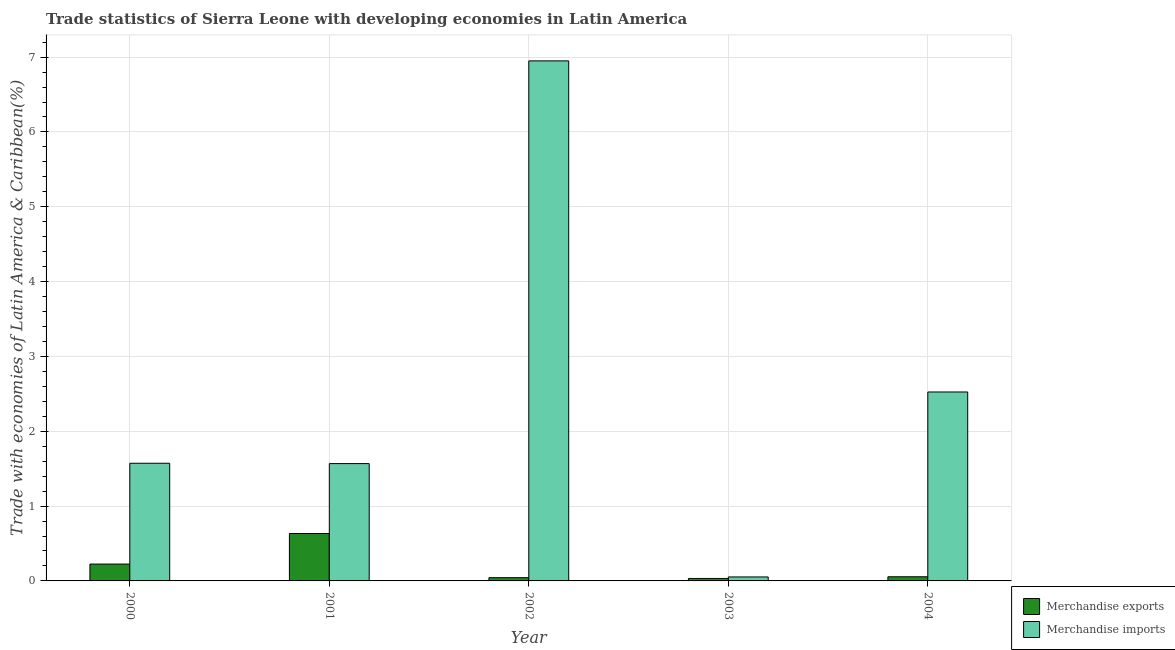How many different coloured bars are there?
Provide a succinct answer. 2. Are the number of bars on each tick of the X-axis equal?
Ensure brevity in your answer.  Yes. What is the merchandise exports in 2003?
Offer a very short reply. 0.03. Across all years, what is the maximum merchandise exports?
Give a very brief answer. 0.63. Across all years, what is the minimum merchandise exports?
Provide a short and direct response. 0.03. In which year was the merchandise exports maximum?
Keep it short and to the point. 2001. What is the total merchandise exports in the graph?
Offer a very short reply. 0.99. What is the difference between the merchandise imports in 2000 and that in 2001?
Your answer should be very brief. 0. What is the difference between the merchandise imports in 2003 and the merchandise exports in 2002?
Your answer should be very brief. -6.9. What is the average merchandise imports per year?
Your answer should be very brief. 2.53. In how many years, is the merchandise imports greater than 1 %?
Offer a very short reply. 4. What is the ratio of the merchandise exports in 2002 to that in 2003?
Provide a succinct answer. 1.32. Is the difference between the merchandise exports in 2000 and 2004 greater than the difference between the merchandise imports in 2000 and 2004?
Offer a terse response. No. What is the difference between the highest and the second highest merchandise imports?
Offer a very short reply. 4.42. What is the difference between the highest and the lowest merchandise imports?
Give a very brief answer. 6.9. Is the sum of the merchandise imports in 2001 and 2002 greater than the maximum merchandise exports across all years?
Provide a short and direct response. Yes. What does the 2nd bar from the right in 2002 represents?
Your answer should be very brief. Merchandise exports. How many years are there in the graph?
Give a very brief answer. 5. What is the difference between two consecutive major ticks on the Y-axis?
Your answer should be compact. 1. Are the values on the major ticks of Y-axis written in scientific E-notation?
Provide a short and direct response. No. Does the graph contain any zero values?
Offer a very short reply. No. Where does the legend appear in the graph?
Keep it short and to the point. Bottom right. How many legend labels are there?
Make the answer very short. 2. How are the legend labels stacked?
Give a very brief answer. Vertical. What is the title of the graph?
Offer a very short reply. Trade statistics of Sierra Leone with developing economies in Latin America. What is the label or title of the X-axis?
Offer a very short reply. Year. What is the label or title of the Y-axis?
Keep it short and to the point. Trade with economies of Latin America & Caribbean(%). What is the Trade with economies of Latin America & Caribbean(%) of Merchandise exports in 2000?
Your response must be concise. 0.23. What is the Trade with economies of Latin America & Caribbean(%) of Merchandise imports in 2000?
Offer a very short reply. 1.57. What is the Trade with economies of Latin America & Caribbean(%) in Merchandise exports in 2001?
Provide a succinct answer. 0.63. What is the Trade with economies of Latin America & Caribbean(%) in Merchandise imports in 2001?
Offer a very short reply. 1.57. What is the Trade with economies of Latin America & Caribbean(%) of Merchandise exports in 2002?
Your answer should be compact. 0.04. What is the Trade with economies of Latin America & Caribbean(%) of Merchandise imports in 2002?
Offer a very short reply. 6.95. What is the Trade with economies of Latin America & Caribbean(%) of Merchandise exports in 2003?
Provide a short and direct response. 0.03. What is the Trade with economies of Latin America & Caribbean(%) of Merchandise imports in 2003?
Keep it short and to the point. 0.05. What is the Trade with economies of Latin America & Caribbean(%) of Merchandise exports in 2004?
Give a very brief answer. 0.06. What is the Trade with economies of Latin America & Caribbean(%) of Merchandise imports in 2004?
Your response must be concise. 2.53. Across all years, what is the maximum Trade with economies of Latin America & Caribbean(%) in Merchandise exports?
Your answer should be very brief. 0.63. Across all years, what is the maximum Trade with economies of Latin America & Caribbean(%) in Merchandise imports?
Offer a terse response. 6.95. Across all years, what is the minimum Trade with economies of Latin America & Caribbean(%) of Merchandise exports?
Your answer should be compact. 0.03. Across all years, what is the minimum Trade with economies of Latin America & Caribbean(%) of Merchandise imports?
Keep it short and to the point. 0.05. What is the total Trade with economies of Latin America & Caribbean(%) of Merchandise exports in the graph?
Your response must be concise. 0.99. What is the total Trade with economies of Latin America & Caribbean(%) of Merchandise imports in the graph?
Provide a short and direct response. 12.67. What is the difference between the Trade with economies of Latin America & Caribbean(%) in Merchandise exports in 2000 and that in 2001?
Offer a very short reply. -0.41. What is the difference between the Trade with economies of Latin America & Caribbean(%) in Merchandise imports in 2000 and that in 2001?
Provide a succinct answer. 0. What is the difference between the Trade with economies of Latin America & Caribbean(%) of Merchandise exports in 2000 and that in 2002?
Give a very brief answer. 0.18. What is the difference between the Trade with economies of Latin America & Caribbean(%) in Merchandise imports in 2000 and that in 2002?
Make the answer very short. -5.38. What is the difference between the Trade with economies of Latin America & Caribbean(%) of Merchandise exports in 2000 and that in 2003?
Keep it short and to the point. 0.19. What is the difference between the Trade with economies of Latin America & Caribbean(%) in Merchandise imports in 2000 and that in 2003?
Give a very brief answer. 1.52. What is the difference between the Trade with economies of Latin America & Caribbean(%) in Merchandise exports in 2000 and that in 2004?
Offer a very short reply. 0.17. What is the difference between the Trade with economies of Latin America & Caribbean(%) of Merchandise imports in 2000 and that in 2004?
Provide a short and direct response. -0.95. What is the difference between the Trade with economies of Latin America & Caribbean(%) in Merchandise exports in 2001 and that in 2002?
Offer a terse response. 0.59. What is the difference between the Trade with economies of Latin America & Caribbean(%) of Merchandise imports in 2001 and that in 2002?
Ensure brevity in your answer.  -5.38. What is the difference between the Trade with economies of Latin America & Caribbean(%) of Merchandise exports in 2001 and that in 2003?
Your answer should be compact. 0.6. What is the difference between the Trade with economies of Latin America & Caribbean(%) of Merchandise imports in 2001 and that in 2003?
Offer a terse response. 1.51. What is the difference between the Trade with economies of Latin America & Caribbean(%) of Merchandise exports in 2001 and that in 2004?
Keep it short and to the point. 0.58. What is the difference between the Trade with economies of Latin America & Caribbean(%) of Merchandise imports in 2001 and that in 2004?
Keep it short and to the point. -0.96. What is the difference between the Trade with economies of Latin America & Caribbean(%) of Merchandise exports in 2002 and that in 2003?
Keep it short and to the point. 0.01. What is the difference between the Trade with economies of Latin America & Caribbean(%) in Merchandise imports in 2002 and that in 2003?
Provide a succinct answer. 6.9. What is the difference between the Trade with economies of Latin America & Caribbean(%) of Merchandise exports in 2002 and that in 2004?
Make the answer very short. -0.01. What is the difference between the Trade with economies of Latin America & Caribbean(%) of Merchandise imports in 2002 and that in 2004?
Your answer should be very brief. 4.42. What is the difference between the Trade with economies of Latin America & Caribbean(%) of Merchandise exports in 2003 and that in 2004?
Give a very brief answer. -0.02. What is the difference between the Trade with economies of Latin America & Caribbean(%) of Merchandise imports in 2003 and that in 2004?
Ensure brevity in your answer.  -2.47. What is the difference between the Trade with economies of Latin America & Caribbean(%) of Merchandise exports in 2000 and the Trade with economies of Latin America & Caribbean(%) of Merchandise imports in 2001?
Your response must be concise. -1.34. What is the difference between the Trade with economies of Latin America & Caribbean(%) of Merchandise exports in 2000 and the Trade with economies of Latin America & Caribbean(%) of Merchandise imports in 2002?
Give a very brief answer. -6.72. What is the difference between the Trade with economies of Latin America & Caribbean(%) in Merchandise exports in 2000 and the Trade with economies of Latin America & Caribbean(%) in Merchandise imports in 2003?
Your answer should be compact. 0.17. What is the difference between the Trade with economies of Latin America & Caribbean(%) in Merchandise exports in 2000 and the Trade with economies of Latin America & Caribbean(%) in Merchandise imports in 2004?
Your answer should be compact. -2.3. What is the difference between the Trade with economies of Latin America & Caribbean(%) of Merchandise exports in 2001 and the Trade with economies of Latin America & Caribbean(%) of Merchandise imports in 2002?
Give a very brief answer. -6.32. What is the difference between the Trade with economies of Latin America & Caribbean(%) of Merchandise exports in 2001 and the Trade with economies of Latin America & Caribbean(%) of Merchandise imports in 2003?
Your answer should be very brief. 0.58. What is the difference between the Trade with economies of Latin America & Caribbean(%) in Merchandise exports in 2001 and the Trade with economies of Latin America & Caribbean(%) in Merchandise imports in 2004?
Offer a terse response. -1.89. What is the difference between the Trade with economies of Latin America & Caribbean(%) in Merchandise exports in 2002 and the Trade with economies of Latin America & Caribbean(%) in Merchandise imports in 2003?
Keep it short and to the point. -0.01. What is the difference between the Trade with economies of Latin America & Caribbean(%) in Merchandise exports in 2002 and the Trade with economies of Latin America & Caribbean(%) in Merchandise imports in 2004?
Give a very brief answer. -2.48. What is the difference between the Trade with economies of Latin America & Caribbean(%) in Merchandise exports in 2003 and the Trade with economies of Latin America & Caribbean(%) in Merchandise imports in 2004?
Your answer should be very brief. -2.49. What is the average Trade with economies of Latin America & Caribbean(%) of Merchandise exports per year?
Make the answer very short. 0.2. What is the average Trade with economies of Latin America & Caribbean(%) of Merchandise imports per year?
Your answer should be compact. 2.53. In the year 2000, what is the difference between the Trade with economies of Latin America & Caribbean(%) of Merchandise exports and Trade with economies of Latin America & Caribbean(%) of Merchandise imports?
Offer a very short reply. -1.35. In the year 2001, what is the difference between the Trade with economies of Latin America & Caribbean(%) of Merchandise exports and Trade with economies of Latin America & Caribbean(%) of Merchandise imports?
Your response must be concise. -0.93. In the year 2002, what is the difference between the Trade with economies of Latin America & Caribbean(%) in Merchandise exports and Trade with economies of Latin America & Caribbean(%) in Merchandise imports?
Your answer should be very brief. -6.91. In the year 2003, what is the difference between the Trade with economies of Latin America & Caribbean(%) in Merchandise exports and Trade with economies of Latin America & Caribbean(%) in Merchandise imports?
Your answer should be very brief. -0.02. In the year 2004, what is the difference between the Trade with economies of Latin America & Caribbean(%) in Merchandise exports and Trade with economies of Latin America & Caribbean(%) in Merchandise imports?
Offer a very short reply. -2.47. What is the ratio of the Trade with economies of Latin America & Caribbean(%) of Merchandise exports in 2000 to that in 2001?
Offer a terse response. 0.36. What is the ratio of the Trade with economies of Latin America & Caribbean(%) in Merchandise imports in 2000 to that in 2001?
Your answer should be compact. 1. What is the ratio of the Trade with economies of Latin America & Caribbean(%) in Merchandise exports in 2000 to that in 2002?
Offer a terse response. 5.2. What is the ratio of the Trade with economies of Latin America & Caribbean(%) in Merchandise imports in 2000 to that in 2002?
Give a very brief answer. 0.23. What is the ratio of the Trade with economies of Latin America & Caribbean(%) of Merchandise exports in 2000 to that in 2003?
Ensure brevity in your answer.  6.85. What is the ratio of the Trade with economies of Latin America & Caribbean(%) in Merchandise imports in 2000 to that in 2003?
Ensure brevity in your answer.  29.54. What is the ratio of the Trade with economies of Latin America & Caribbean(%) in Merchandise exports in 2000 to that in 2004?
Your answer should be compact. 4.07. What is the ratio of the Trade with economies of Latin America & Caribbean(%) in Merchandise imports in 2000 to that in 2004?
Make the answer very short. 0.62. What is the ratio of the Trade with economies of Latin America & Caribbean(%) in Merchandise exports in 2001 to that in 2002?
Make the answer very short. 14.62. What is the ratio of the Trade with economies of Latin America & Caribbean(%) of Merchandise imports in 2001 to that in 2002?
Your answer should be very brief. 0.23. What is the ratio of the Trade with economies of Latin America & Caribbean(%) of Merchandise exports in 2001 to that in 2003?
Ensure brevity in your answer.  19.27. What is the ratio of the Trade with economies of Latin America & Caribbean(%) of Merchandise imports in 2001 to that in 2003?
Offer a very short reply. 29.45. What is the ratio of the Trade with economies of Latin America & Caribbean(%) in Merchandise exports in 2001 to that in 2004?
Provide a short and direct response. 11.44. What is the ratio of the Trade with economies of Latin America & Caribbean(%) of Merchandise imports in 2001 to that in 2004?
Provide a short and direct response. 0.62. What is the ratio of the Trade with economies of Latin America & Caribbean(%) of Merchandise exports in 2002 to that in 2003?
Ensure brevity in your answer.  1.32. What is the ratio of the Trade with economies of Latin America & Caribbean(%) of Merchandise imports in 2002 to that in 2003?
Keep it short and to the point. 130.57. What is the ratio of the Trade with economies of Latin America & Caribbean(%) in Merchandise exports in 2002 to that in 2004?
Keep it short and to the point. 0.78. What is the ratio of the Trade with economies of Latin America & Caribbean(%) of Merchandise imports in 2002 to that in 2004?
Ensure brevity in your answer.  2.75. What is the ratio of the Trade with economies of Latin America & Caribbean(%) in Merchandise exports in 2003 to that in 2004?
Your answer should be very brief. 0.59. What is the ratio of the Trade with economies of Latin America & Caribbean(%) of Merchandise imports in 2003 to that in 2004?
Your answer should be compact. 0.02. What is the difference between the highest and the second highest Trade with economies of Latin America & Caribbean(%) of Merchandise exports?
Make the answer very short. 0.41. What is the difference between the highest and the second highest Trade with economies of Latin America & Caribbean(%) in Merchandise imports?
Provide a short and direct response. 4.42. What is the difference between the highest and the lowest Trade with economies of Latin America & Caribbean(%) of Merchandise exports?
Offer a very short reply. 0.6. What is the difference between the highest and the lowest Trade with economies of Latin America & Caribbean(%) of Merchandise imports?
Give a very brief answer. 6.9. 